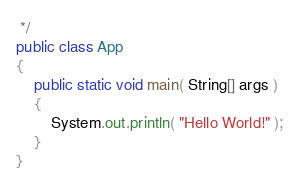Convert code to text. <code><loc_0><loc_0><loc_500><loc_500><_Java_> */
public class App 
{
    public static void main( String[] args )
    {
        System.out.println( "Hello World!" );
    }
}
</code> 